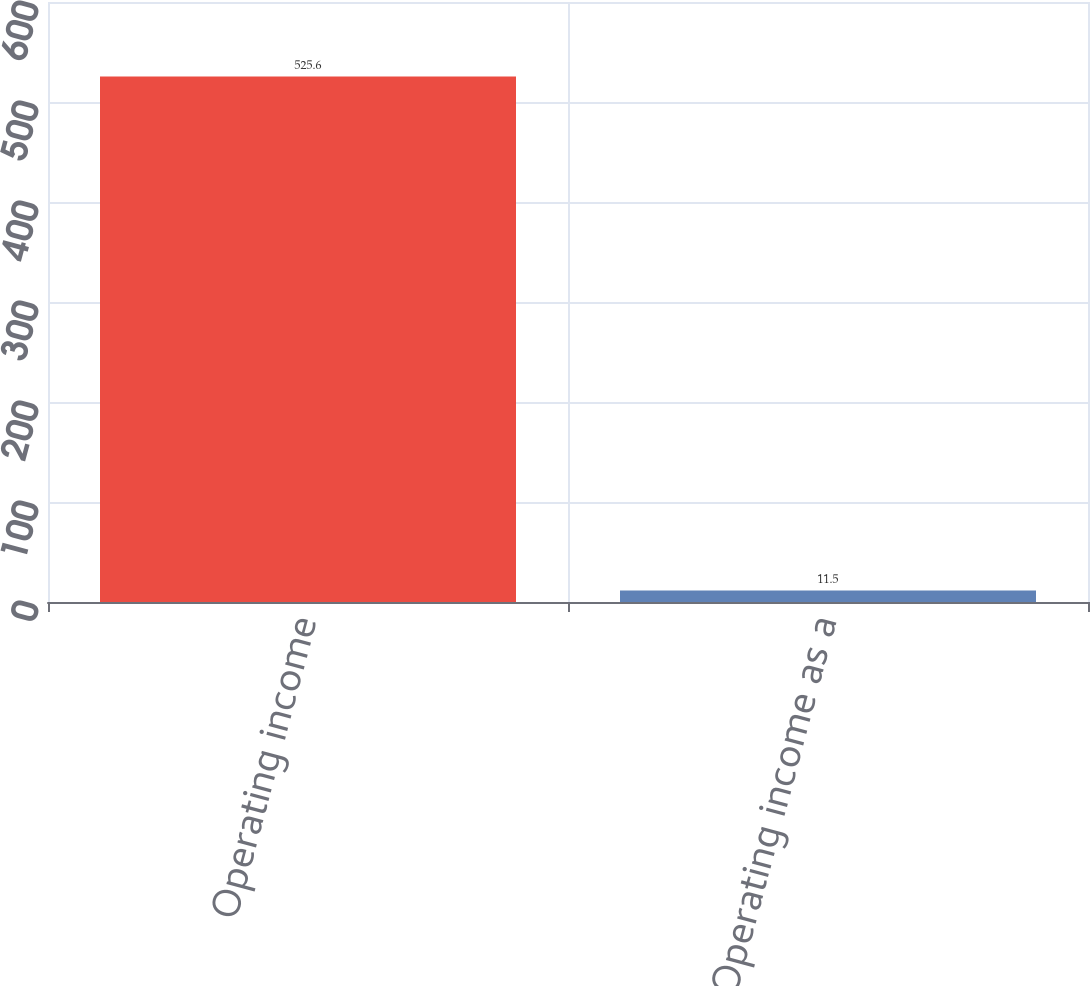Convert chart. <chart><loc_0><loc_0><loc_500><loc_500><bar_chart><fcel>Operating income<fcel>Operating income as a<nl><fcel>525.6<fcel>11.5<nl></chart> 